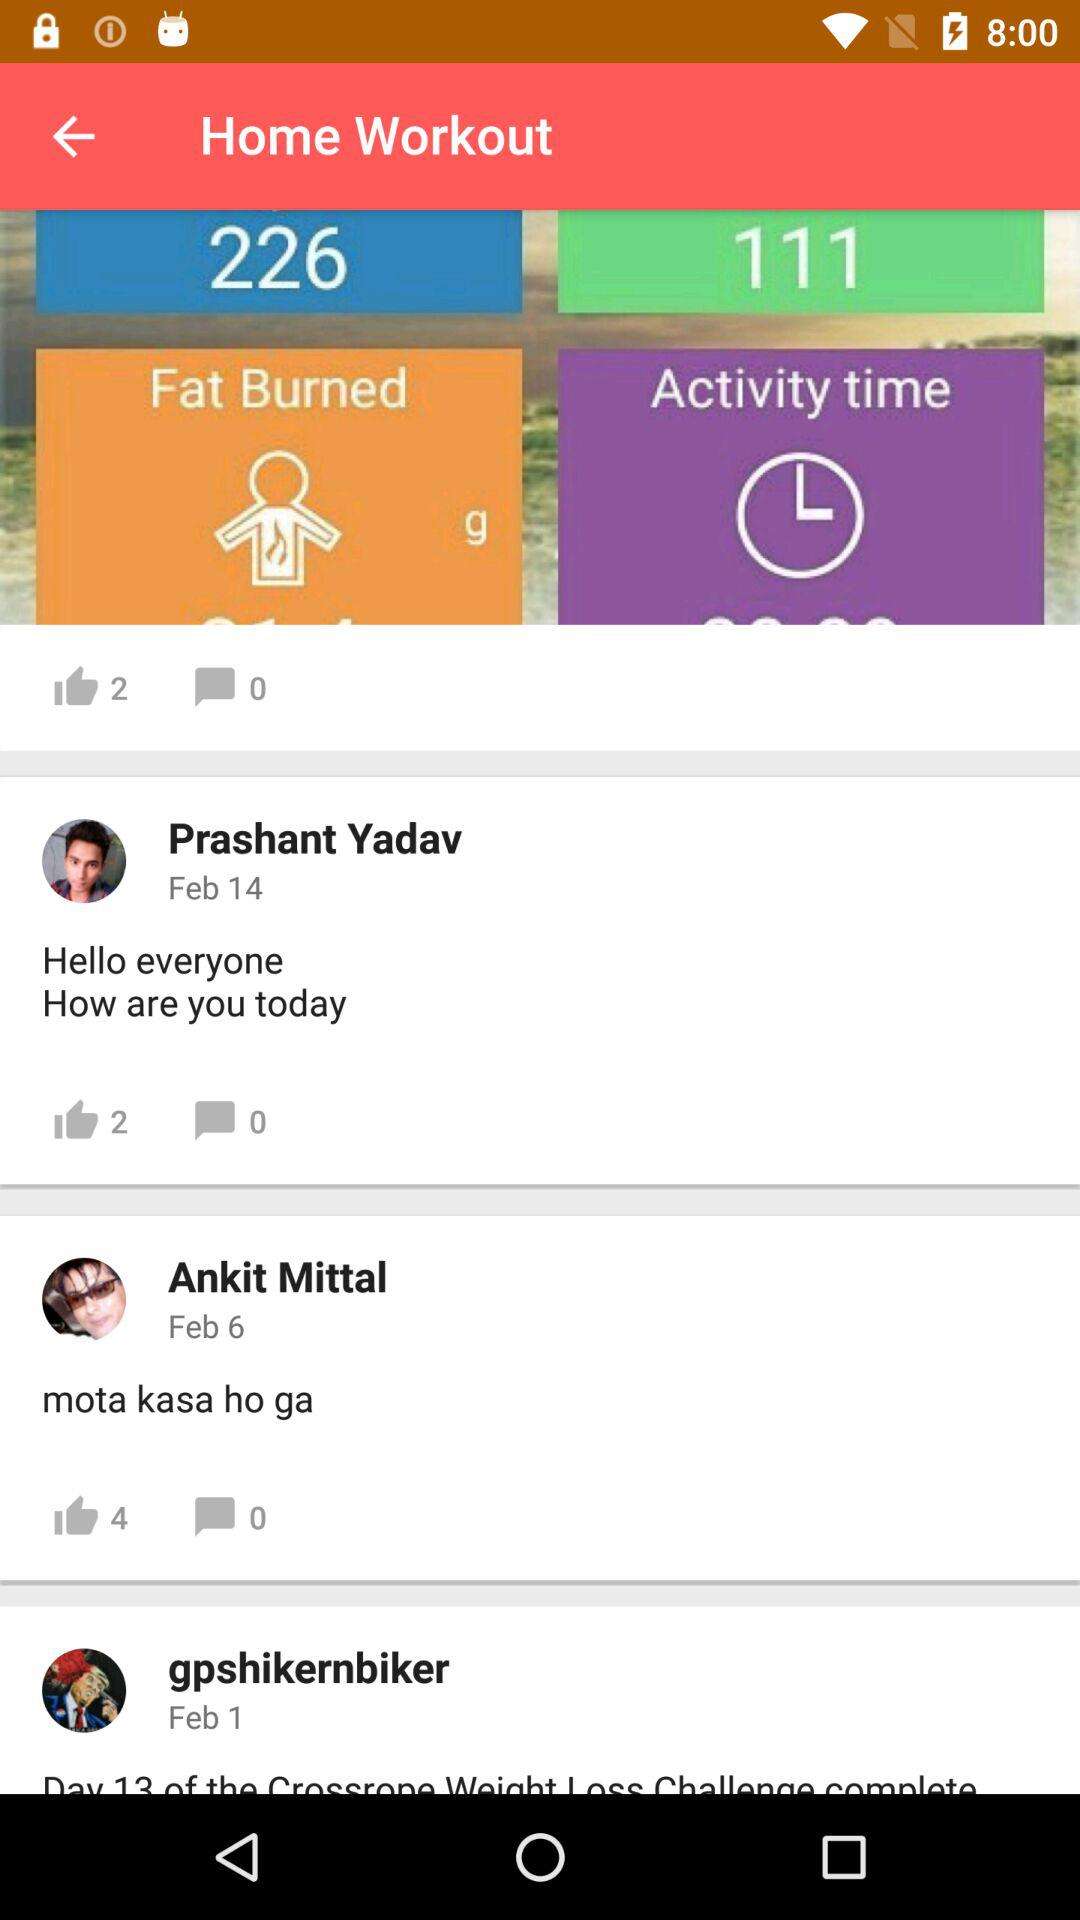What's the date of Prashant Yadav's comment? The date of Prashant Yadav's comment is February 14. 